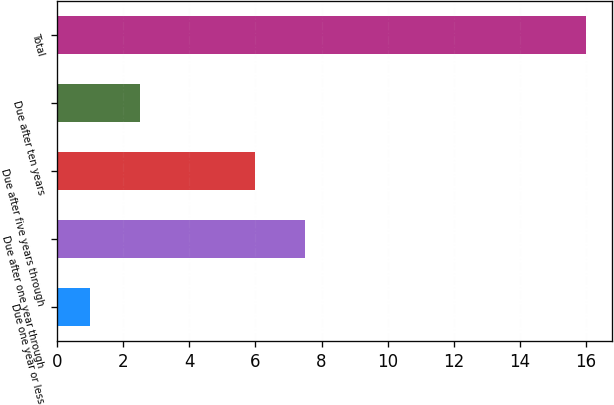Convert chart to OTSL. <chart><loc_0><loc_0><loc_500><loc_500><bar_chart><fcel>Due one year or less<fcel>Due after one year through<fcel>Due after five years through<fcel>Due after ten years<fcel>Total<nl><fcel>1<fcel>7.5<fcel>6<fcel>2.5<fcel>16<nl></chart> 